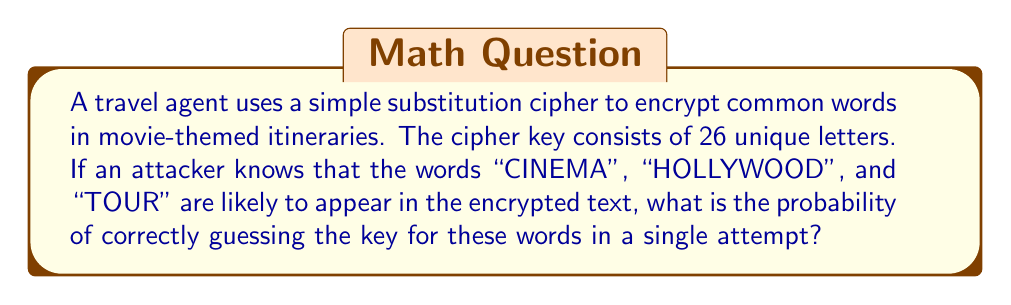What is the answer to this math problem? Let's approach this step-by-step:

1) In a simple substitution cipher, each letter is replaced by another letter consistently throughout the text.

2) We need to consider the unique letters in the words "CINEMA", "HOLLYWOOD", and "TOUR":
   C, I, N, E, M, A, H, O, L, Y, W, D, T, U, R
   There are 15 unique letters.

3) For the first letter, we have 26 choices out of 26 letters:
   $P_1 = \frac{26}{26} = 1$

4) For the second letter, we have 25 choices out of the remaining 25 letters:
   $P_2 = \frac{25}{25} = 1$

5) This continues for all 15 unique letters. The probability for the last (15th) letter will be:
   $P_{15} = \frac{12}{12} = 1$

6) The probability of correctly guessing all 15 letters in order is the product of these individual probabilities:

   $$P = P_1 \times P_2 \times ... \times P_{15}$$
   $$P = 1 \times 1 \times ... \times 1 = 1$$

7) However, this is only for the 15 letters we know. The remaining 11 letters of the alphabet can be arranged in 11! ways.

8) Therefore, the final probability is:

   $$P_{final} = \frac{1}{11!} = \frac{1}{39,916,800}$$
Answer: $\frac{1}{39,916,800}$ 